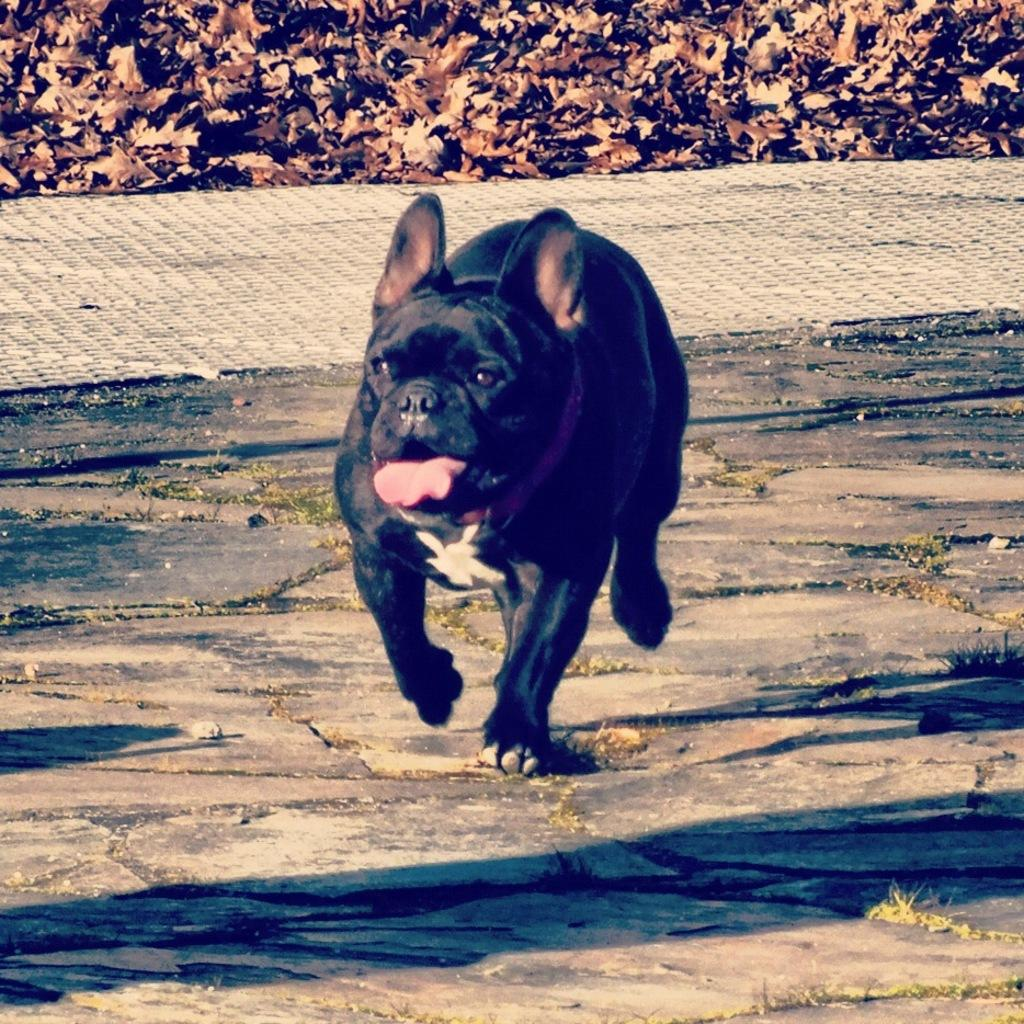What animal can be seen in the image? There is a dog in the image. What is the dog doing in the image? The dog is running on the ground. What can be seen in the background of the image? There are leaves visible in the background of the image. Where is the faucet located in the image? There is no faucet present in the image. What type of experience does the dog have while running in the image? The image does not provide information about the dog's experience while running; it only shows the dog running on the ground. 